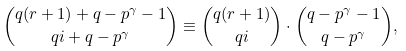Convert formula to latex. <formula><loc_0><loc_0><loc_500><loc_500>\binom { q ( r + 1 ) + q - p ^ { \gamma } - 1 } { q i + q - p ^ { \gamma } } \equiv \binom { q ( r + 1 ) } { q i } \cdot \binom { q - p ^ { \gamma } - 1 } { q - p ^ { \gamma } } ,</formula> 